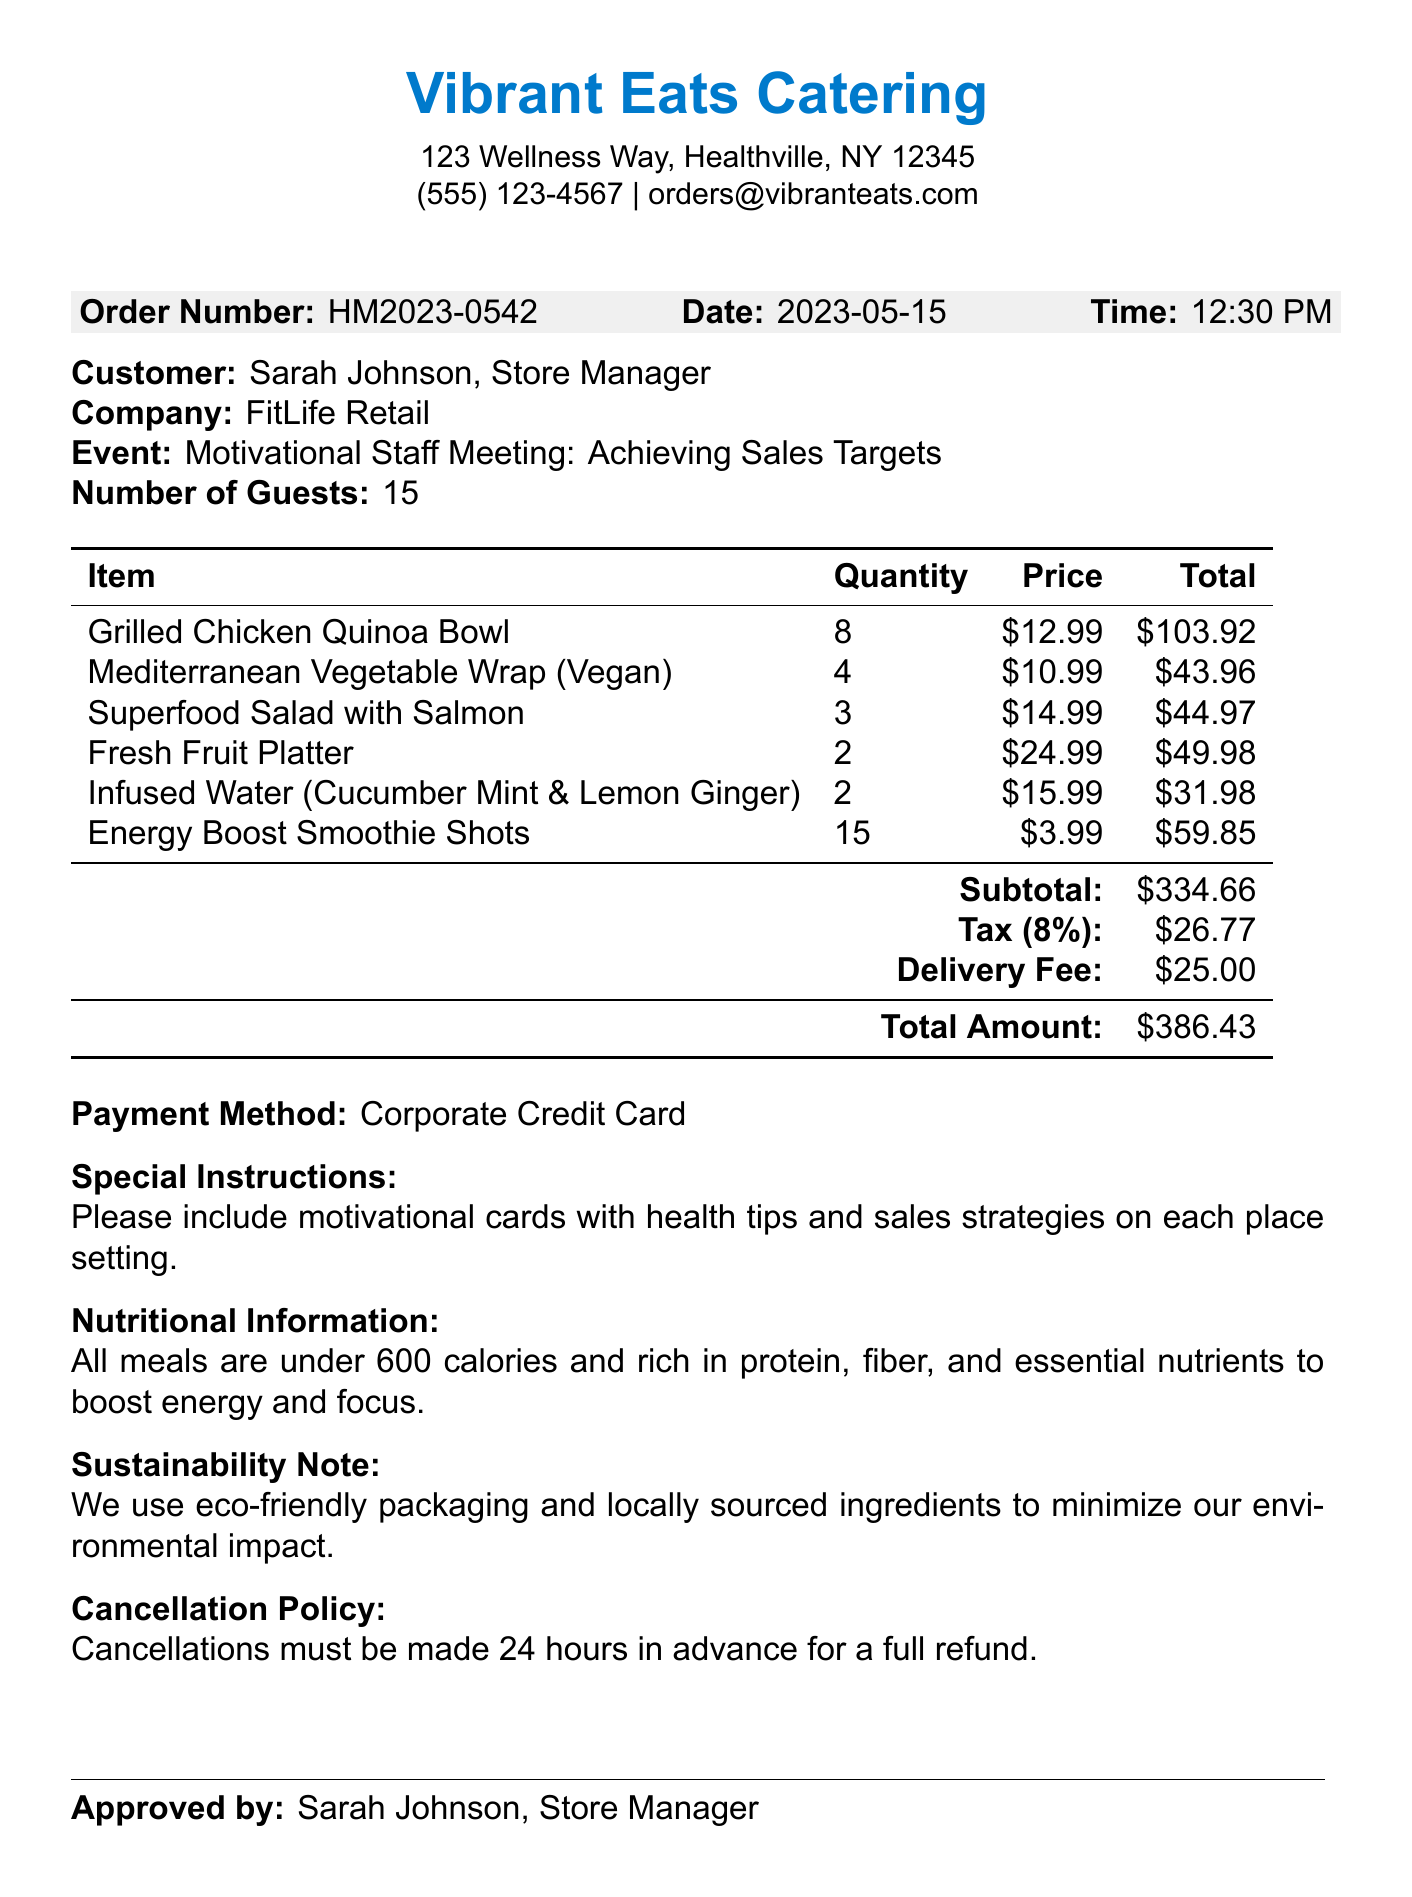What is the business name? The business name is provided at the top of the receipt.
Answer: Vibrant Eats Catering What is the order number? The order number can be found in the order details section of the document.
Answer: HM2023-0542 How many guests were at the event? The number of guests is listed in the event details.
Answer: 15 What was included in the special instructions? The special instructions section details requests for the order.
Answer: Please include motivational cards with health tips and sales strategies on each place setting What is the total amount due? The total amount is indicated at the bottom of the pricing section.
Answer: $386.43 What type of payment was used? The payment method is specified in the document.
Answer: Corporate Credit Card How many Grilled Chicken Quinoa Bowls were ordered? The quantity of Grilled Chicken Quinoa Bowls is specified in the menu items list.
Answer: 8 What is the cancellation policy? The cancellation policy is stated in a dedicated section.
Answer: Cancellations must be made 24 hours in advance for a full refund What is the tax amount? The tax amount is listed in the pricing breakdown of the document.
Answer: $26.77 